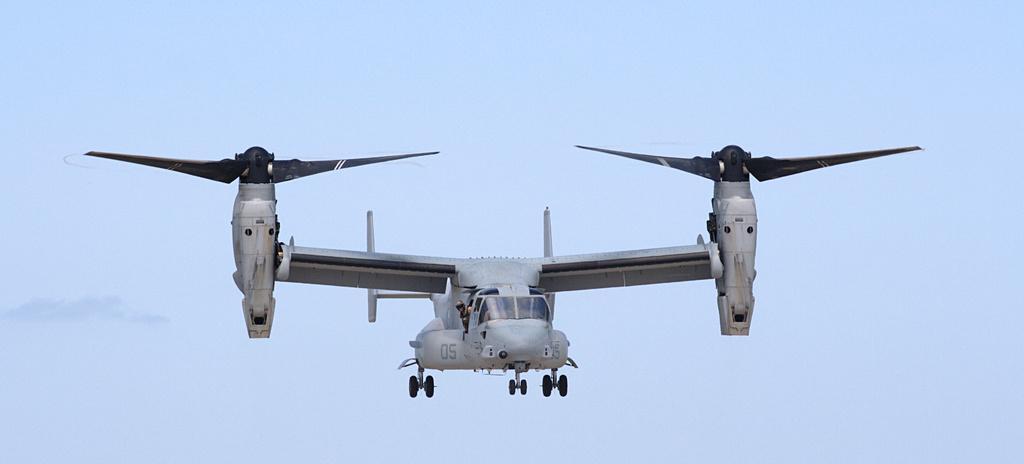Describe this image in one or two sentences. In this image, we can see an aircraft with a person. We can see the sky. 